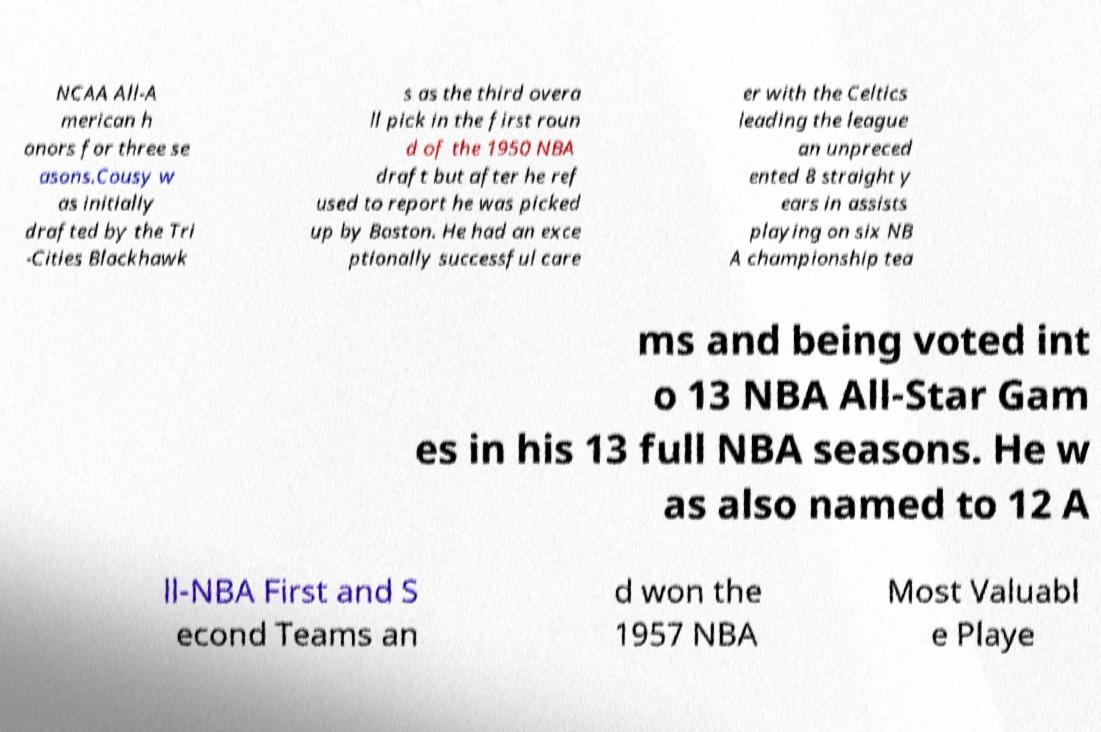Please identify and transcribe the text found in this image. NCAA All-A merican h onors for three se asons.Cousy w as initially drafted by the Tri -Cities Blackhawk s as the third overa ll pick in the first roun d of the 1950 NBA draft but after he ref used to report he was picked up by Boston. He had an exce ptionally successful care er with the Celtics leading the league an unpreced ented 8 straight y ears in assists playing on six NB A championship tea ms and being voted int o 13 NBA All-Star Gam es in his 13 full NBA seasons. He w as also named to 12 A ll-NBA First and S econd Teams an d won the 1957 NBA Most Valuabl e Playe 